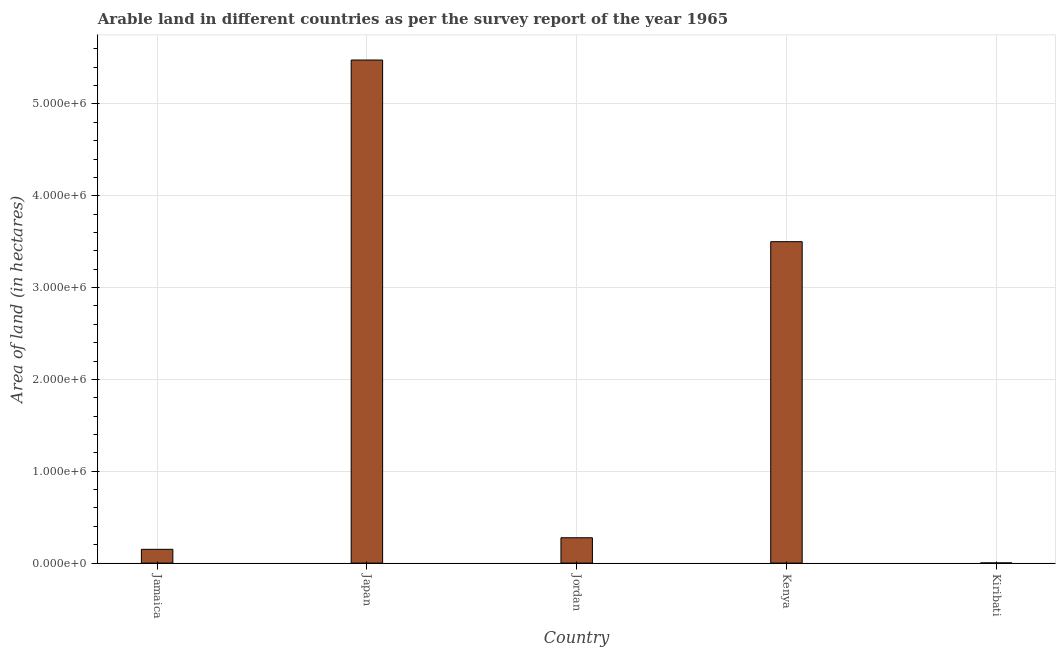Does the graph contain grids?
Make the answer very short. Yes. What is the title of the graph?
Your response must be concise. Arable land in different countries as per the survey report of the year 1965. What is the label or title of the Y-axis?
Keep it short and to the point. Area of land (in hectares). Across all countries, what is the maximum area of land?
Your answer should be compact. 5.48e+06. In which country was the area of land minimum?
Your response must be concise. Kiribati. What is the sum of the area of land?
Give a very brief answer. 9.41e+06. What is the difference between the area of land in Kenya and Kiribati?
Keep it short and to the point. 3.50e+06. What is the average area of land per country?
Your answer should be compact. 1.88e+06. What is the median area of land?
Your response must be concise. 2.76e+05. What is the ratio of the area of land in Jamaica to that in Jordan?
Give a very brief answer. 0.54. Is the area of land in Jordan less than that in Kenya?
Your answer should be very brief. Yes. What is the difference between the highest and the second highest area of land?
Your answer should be very brief. 1.98e+06. Is the sum of the area of land in Jamaica and Japan greater than the maximum area of land across all countries?
Your response must be concise. Yes. What is the difference between the highest and the lowest area of land?
Make the answer very short. 5.48e+06. Are all the bars in the graph horizontal?
Offer a terse response. No. How many countries are there in the graph?
Your answer should be compact. 5. What is the difference between two consecutive major ticks on the Y-axis?
Give a very brief answer. 1.00e+06. What is the Area of land (in hectares) of Jamaica?
Provide a short and direct response. 1.50e+05. What is the Area of land (in hectares) of Japan?
Give a very brief answer. 5.48e+06. What is the Area of land (in hectares) of Jordan?
Keep it short and to the point. 2.76e+05. What is the Area of land (in hectares) of Kenya?
Offer a terse response. 3.50e+06. What is the Area of land (in hectares) of Kiribati?
Provide a succinct answer. 2000. What is the difference between the Area of land (in hectares) in Jamaica and Japan?
Your response must be concise. -5.33e+06. What is the difference between the Area of land (in hectares) in Jamaica and Jordan?
Ensure brevity in your answer.  -1.26e+05. What is the difference between the Area of land (in hectares) in Jamaica and Kenya?
Your response must be concise. -3.35e+06. What is the difference between the Area of land (in hectares) in Jamaica and Kiribati?
Offer a very short reply. 1.48e+05. What is the difference between the Area of land (in hectares) in Japan and Jordan?
Give a very brief answer. 5.20e+06. What is the difference between the Area of land (in hectares) in Japan and Kenya?
Your response must be concise. 1.98e+06. What is the difference between the Area of land (in hectares) in Japan and Kiribati?
Ensure brevity in your answer.  5.48e+06. What is the difference between the Area of land (in hectares) in Jordan and Kenya?
Your answer should be very brief. -3.22e+06. What is the difference between the Area of land (in hectares) in Jordan and Kiribati?
Give a very brief answer. 2.74e+05. What is the difference between the Area of land (in hectares) in Kenya and Kiribati?
Make the answer very short. 3.50e+06. What is the ratio of the Area of land (in hectares) in Jamaica to that in Japan?
Give a very brief answer. 0.03. What is the ratio of the Area of land (in hectares) in Jamaica to that in Jordan?
Offer a terse response. 0.54. What is the ratio of the Area of land (in hectares) in Jamaica to that in Kenya?
Your response must be concise. 0.04. What is the ratio of the Area of land (in hectares) in Jamaica to that in Kiribati?
Give a very brief answer. 75. What is the ratio of the Area of land (in hectares) in Japan to that in Jordan?
Ensure brevity in your answer.  19.85. What is the ratio of the Area of land (in hectares) in Japan to that in Kenya?
Give a very brief answer. 1.56. What is the ratio of the Area of land (in hectares) in Japan to that in Kiribati?
Keep it short and to the point. 2739. What is the ratio of the Area of land (in hectares) in Jordan to that in Kenya?
Provide a short and direct response. 0.08. What is the ratio of the Area of land (in hectares) in Jordan to that in Kiribati?
Your answer should be very brief. 138. What is the ratio of the Area of land (in hectares) in Kenya to that in Kiribati?
Make the answer very short. 1750. 